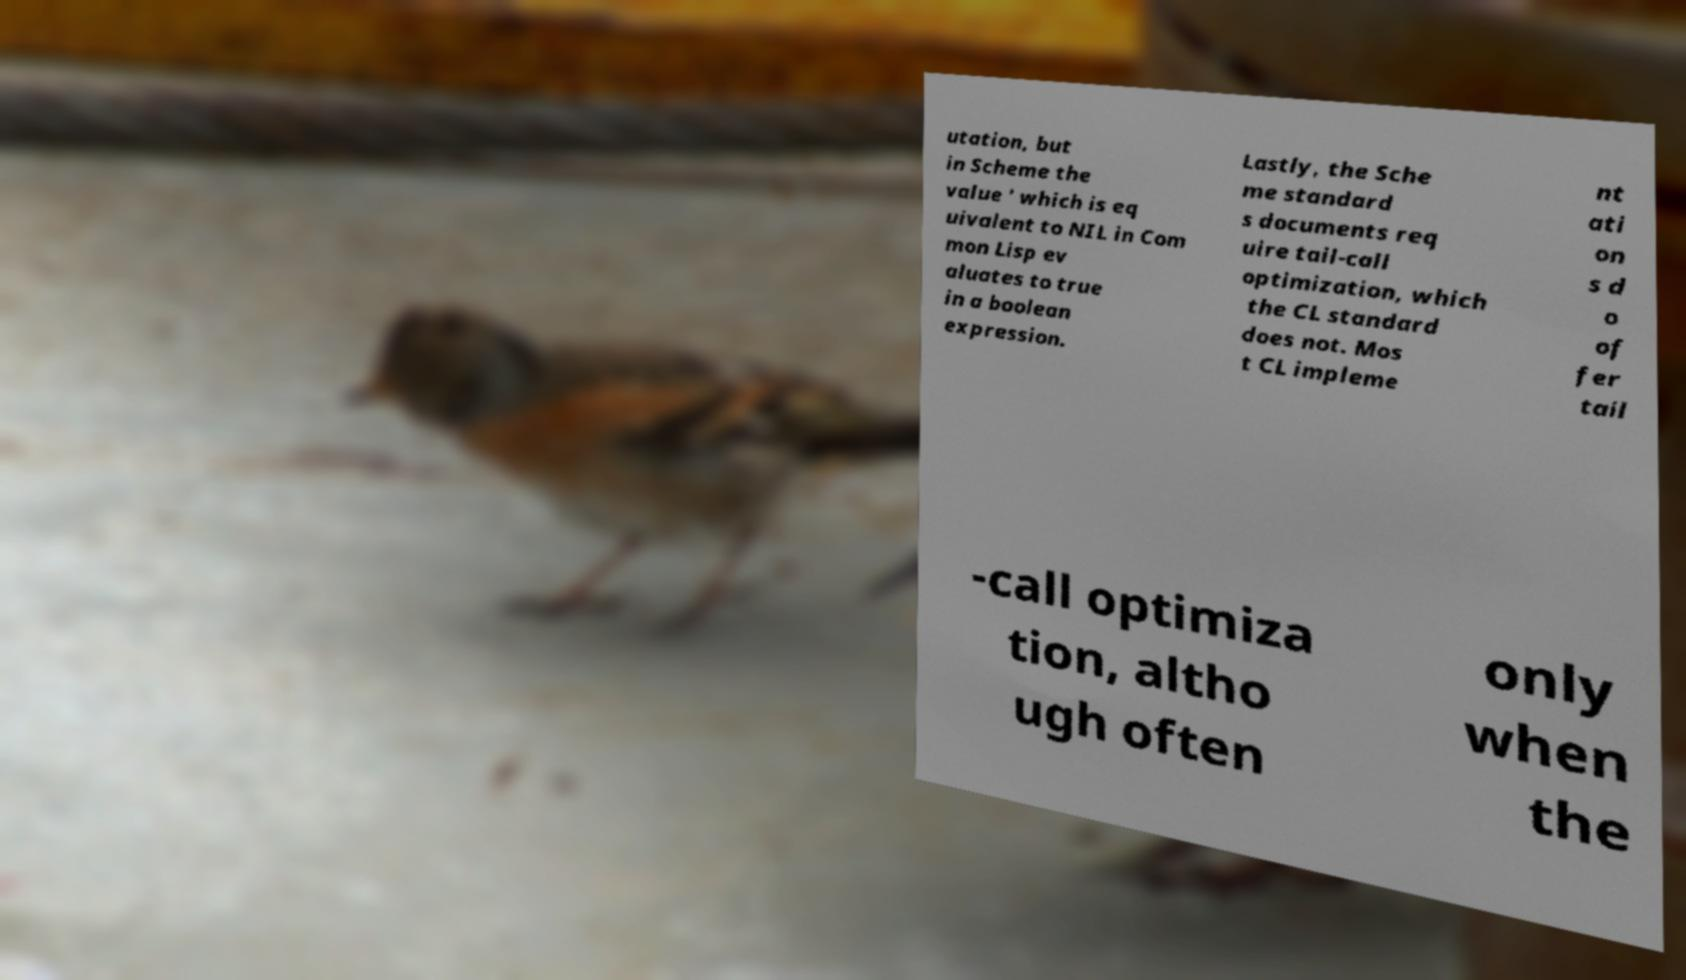Please read and relay the text visible in this image. What does it say? utation, but in Scheme the value ' which is eq uivalent to NIL in Com mon Lisp ev aluates to true in a boolean expression. Lastly, the Sche me standard s documents req uire tail-call optimization, which the CL standard does not. Mos t CL impleme nt ati on s d o of fer tail -call optimiza tion, altho ugh often only when the 